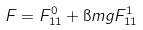Convert formula to latex. <formula><loc_0><loc_0><loc_500><loc_500>F = F ^ { 0 } _ { 1 1 } + \i m g F ^ { 1 } _ { 1 1 }</formula> 